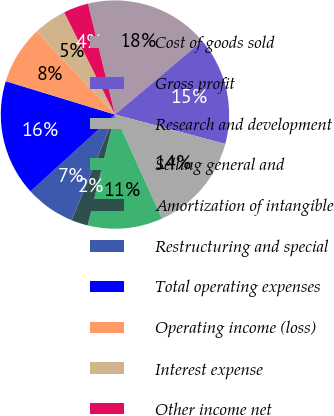Convert chart to OTSL. <chart><loc_0><loc_0><loc_500><loc_500><pie_chart><fcel>Cost of goods sold<fcel>Gross profit<fcel>Research and development<fcel>Selling general and<fcel>Amortization of intangible<fcel>Restructuring and special<fcel>Total operating expenses<fcel>Operating income (loss)<fcel>Interest expense<fcel>Other income net<nl><fcel>17.65%<fcel>15.29%<fcel>14.12%<fcel>10.59%<fcel>2.35%<fcel>7.06%<fcel>16.47%<fcel>8.24%<fcel>4.71%<fcel>3.53%<nl></chart> 